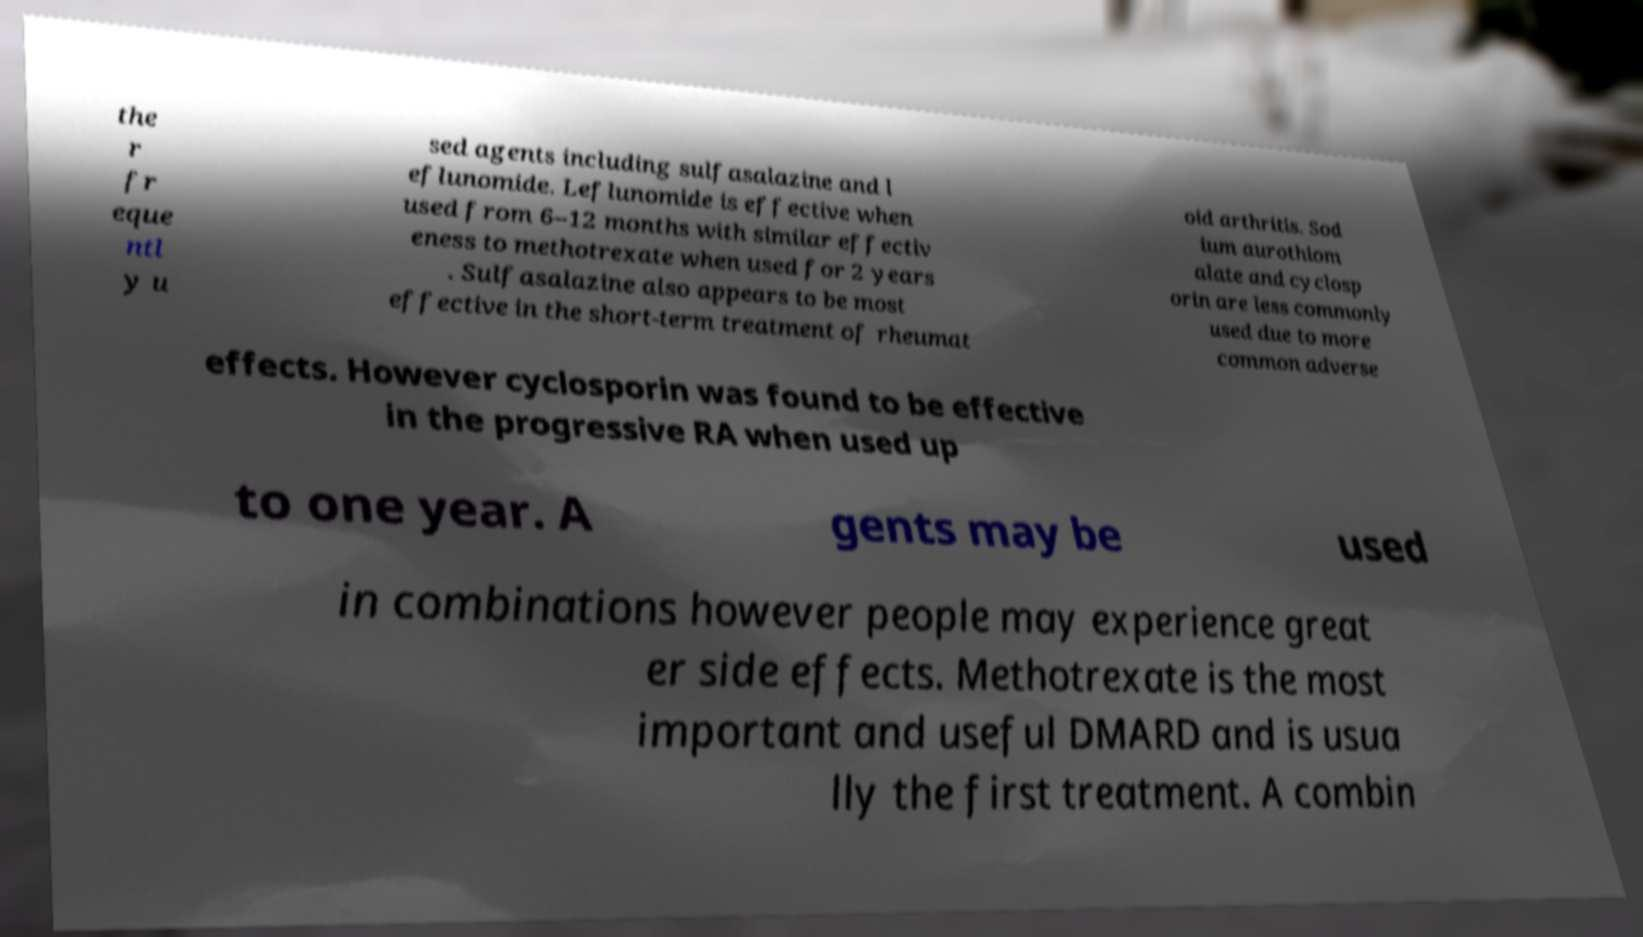I need the written content from this picture converted into text. Can you do that? the r fr eque ntl y u sed agents including sulfasalazine and l eflunomide. Leflunomide is effective when used from 6–12 months with similar effectiv eness to methotrexate when used for 2 years . Sulfasalazine also appears to be most effective in the short-term treatment of rheumat oid arthritis. Sod ium aurothiom alate and cyclosp orin are less commonly used due to more common adverse effects. However cyclosporin was found to be effective in the progressive RA when used up to one year. A gents may be used in combinations however people may experience great er side effects. Methotrexate is the most important and useful DMARD and is usua lly the first treatment. A combin 